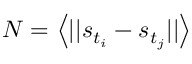Convert formula to latex. <formula><loc_0><loc_0><loc_500><loc_500>N = \left < | | s _ { t _ { i } } - s _ { t _ { j } } | | \right ></formula> 